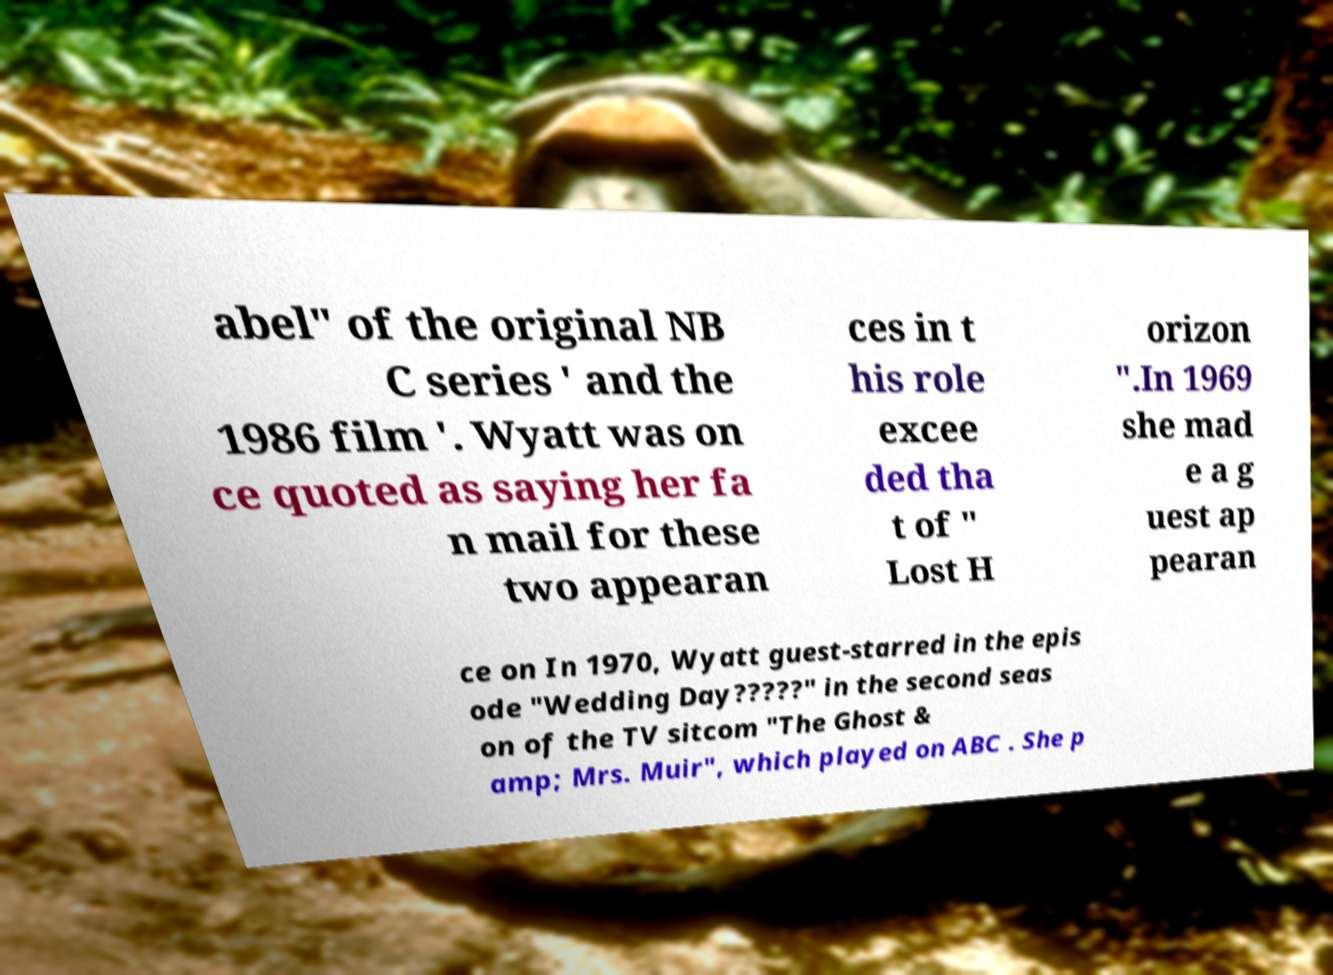Can you read and provide the text displayed in the image?This photo seems to have some interesting text. Can you extract and type it out for me? abel" of the original NB C series ' and the 1986 film '. Wyatt was on ce quoted as saying her fa n mail for these two appearan ces in t his role excee ded tha t of " Lost H orizon ".In 1969 she mad e a g uest ap pearan ce on In 1970, Wyatt guest-starred in the epis ode "Wedding Day?????" in the second seas on of the TV sitcom "The Ghost & amp; Mrs. Muir", which played on ABC . She p 